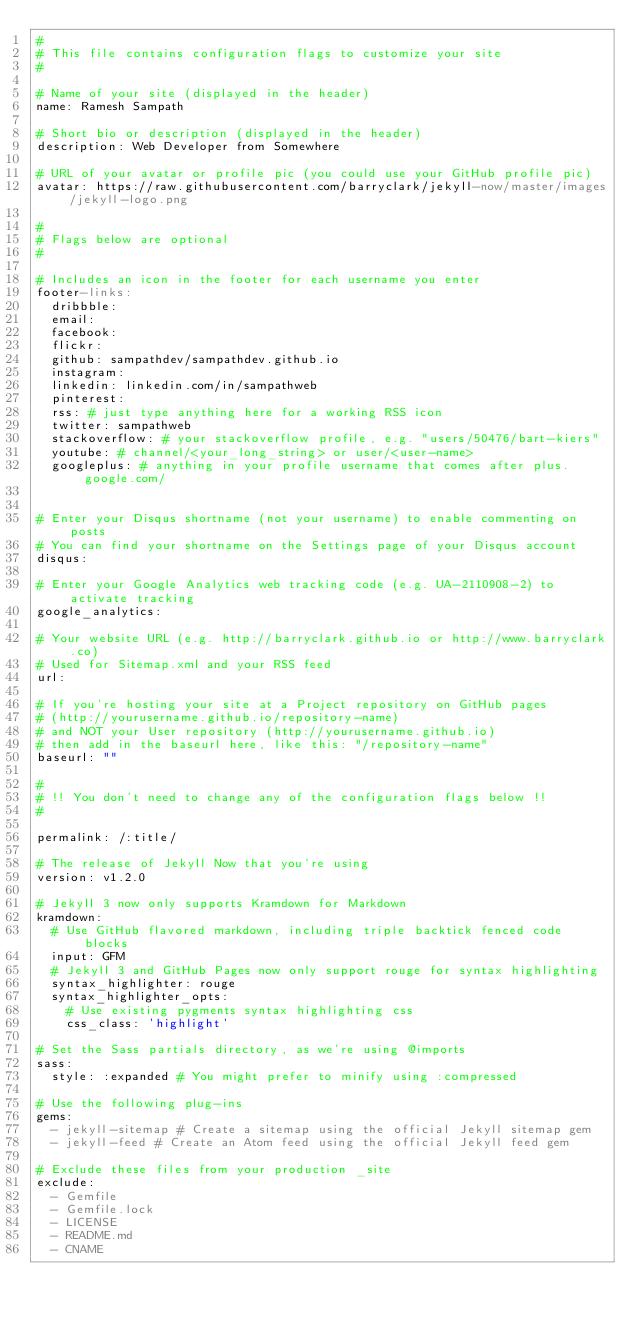<code> <loc_0><loc_0><loc_500><loc_500><_YAML_>#
# This file contains configuration flags to customize your site
#

# Name of your site (displayed in the header)
name: Ramesh Sampath

# Short bio or description (displayed in the header)
description: Web Developer from Somewhere

# URL of your avatar or profile pic (you could use your GitHub profile pic)
avatar: https://raw.githubusercontent.com/barryclark/jekyll-now/master/images/jekyll-logo.png

#
# Flags below are optional
#

# Includes an icon in the footer for each username you enter
footer-links:
  dribbble:
  email:
  facebook:
  flickr:
  github: sampathdev/sampathdev.github.io
  instagram:
  linkedin: linkedin.com/in/sampathweb
  pinterest:
  rss: # just type anything here for a working RSS icon
  twitter: sampathweb
  stackoverflow: # your stackoverflow profile, e.g. "users/50476/bart-kiers"
  youtube: # channel/<your_long_string> or user/<user-name>
  googleplus: # anything in your profile username that comes after plus.google.com/


# Enter your Disqus shortname (not your username) to enable commenting on posts
# You can find your shortname on the Settings page of your Disqus account
disqus:

# Enter your Google Analytics web tracking code (e.g. UA-2110908-2) to activate tracking
google_analytics:

# Your website URL (e.g. http://barryclark.github.io or http://www.barryclark.co)
# Used for Sitemap.xml and your RSS feed
url:

# If you're hosting your site at a Project repository on GitHub pages
# (http://yourusername.github.io/repository-name)
# and NOT your User repository (http://yourusername.github.io)
# then add in the baseurl here, like this: "/repository-name"
baseurl: ""

#
# !! You don't need to change any of the configuration flags below !!
#

permalink: /:title/

# The release of Jekyll Now that you're using
version: v1.2.0

# Jekyll 3 now only supports Kramdown for Markdown
kramdown:
  # Use GitHub flavored markdown, including triple backtick fenced code blocks
  input: GFM
  # Jekyll 3 and GitHub Pages now only support rouge for syntax highlighting
  syntax_highlighter: rouge
  syntax_highlighter_opts:
    # Use existing pygments syntax highlighting css
    css_class: 'highlight'

# Set the Sass partials directory, as we're using @imports
sass:
  style: :expanded # You might prefer to minify using :compressed

# Use the following plug-ins
gems:
  - jekyll-sitemap # Create a sitemap using the official Jekyll sitemap gem
  - jekyll-feed # Create an Atom feed using the official Jekyll feed gem

# Exclude these files from your production _site
exclude:
  - Gemfile
  - Gemfile.lock
  - LICENSE
  - README.md
  - CNAME
</code> 